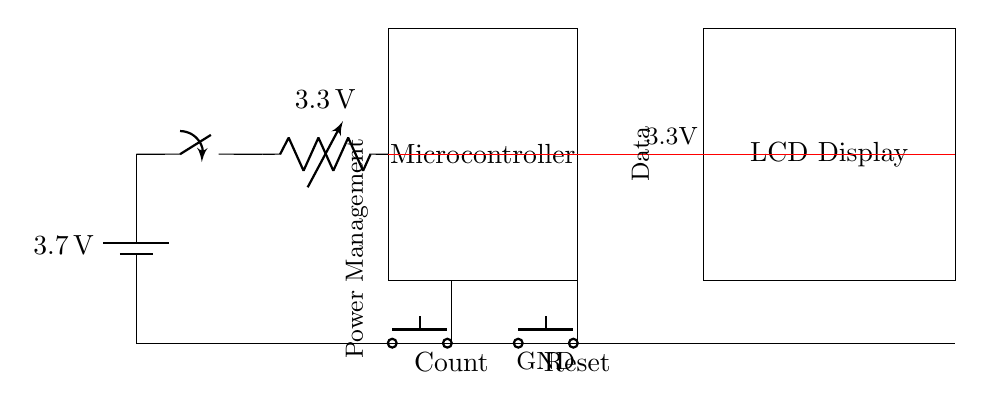What is the type of power source used in this circuit? The circuit diagram shows a battery symbol labeled with a voltage of 3.7 volts, indicating it is a battery-powered device.
Answer: Battery What is the operating voltage of the regulator in this circuit? The voltage regulator in the diagram is labeled with a value of 3.3 volts, which is the output voltage from this component.
Answer: 3.3 volts What is the main function of the microcontroller in this setup? The microcontroller is a critical component that processes input from the buttons and drives the output displayed on the LCD, acting as the central processing unit of this handheld vote counter.
Answer: Processing How many buttons are present in this circuit, and what are their functions? There are two push buttons identified: one is labeled 'Count' for incrementing a count, and the other is 'Reset' for resetting the count to zero.
Answer: Two buttons What is the connection between the microcontroller and the LCD display? The diagram shows a direct data connection from the microcontroller to the LCD display, indicating that the microcontroller sends data to the display for visual output.
Answer: Data connection What is the significance of the ground connection in this circuit? The ground connection provides a reference point for the electrical system, ensuring that all components share a common return path for current, which is essential for stable operation.
Answer: Common reference 